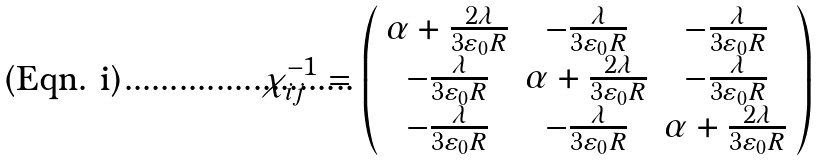<formula> <loc_0><loc_0><loc_500><loc_500>\chi ^ { - 1 } _ { i j } = \left ( \begin{array} { c c c } \alpha + \frac { 2 \lambda } { 3 \varepsilon _ { 0 } R } & - \frac { \lambda } { 3 \varepsilon _ { 0 } R } & - \frac { \lambda } { 3 \varepsilon _ { 0 } R } \\ - \frac { \lambda } { 3 \varepsilon _ { 0 } R } & \alpha + \frac { 2 \lambda } { 3 \varepsilon _ { 0 } R } & - \frac { \lambda } { 3 \varepsilon _ { 0 } R } \\ - \frac { \lambda } { 3 \varepsilon _ { 0 } R } & - \frac { \lambda } { 3 \varepsilon _ { 0 } R } & \alpha + \frac { 2 \lambda } { 3 \varepsilon _ { 0 } R } \end{array} \right )</formula> 